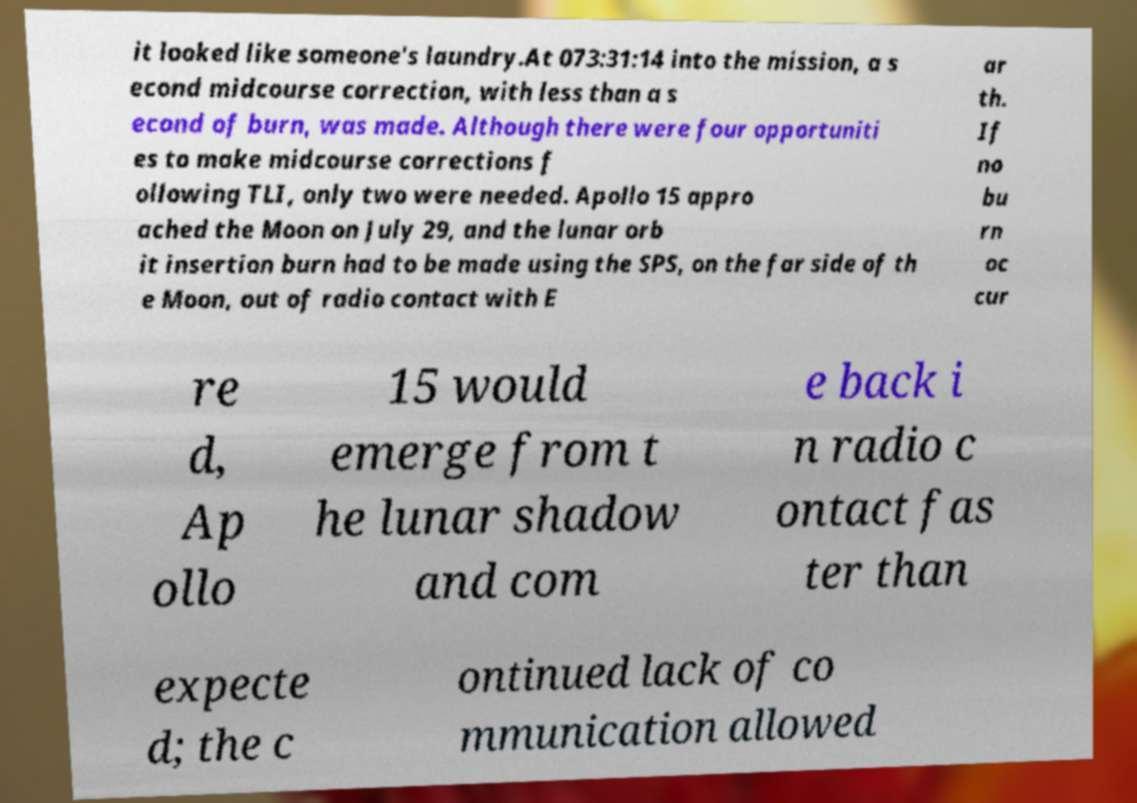Can you read and provide the text displayed in the image?This photo seems to have some interesting text. Can you extract and type it out for me? it looked like someone's laundry.At 073:31:14 into the mission, a s econd midcourse correction, with less than a s econd of burn, was made. Although there were four opportuniti es to make midcourse corrections f ollowing TLI, only two were needed. Apollo 15 appro ached the Moon on July 29, and the lunar orb it insertion burn had to be made using the SPS, on the far side of th e Moon, out of radio contact with E ar th. If no bu rn oc cur re d, Ap ollo 15 would emerge from t he lunar shadow and com e back i n radio c ontact fas ter than expecte d; the c ontinued lack of co mmunication allowed 